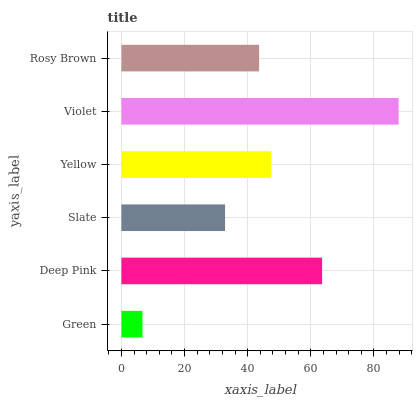Is Green the minimum?
Answer yes or no. Yes. Is Violet the maximum?
Answer yes or no. Yes. Is Deep Pink the minimum?
Answer yes or no. No. Is Deep Pink the maximum?
Answer yes or no. No. Is Deep Pink greater than Green?
Answer yes or no. Yes. Is Green less than Deep Pink?
Answer yes or no. Yes. Is Green greater than Deep Pink?
Answer yes or no. No. Is Deep Pink less than Green?
Answer yes or no. No. Is Yellow the high median?
Answer yes or no. Yes. Is Rosy Brown the low median?
Answer yes or no. Yes. Is Green the high median?
Answer yes or no. No. Is Green the low median?
Answer yes or no. No. 